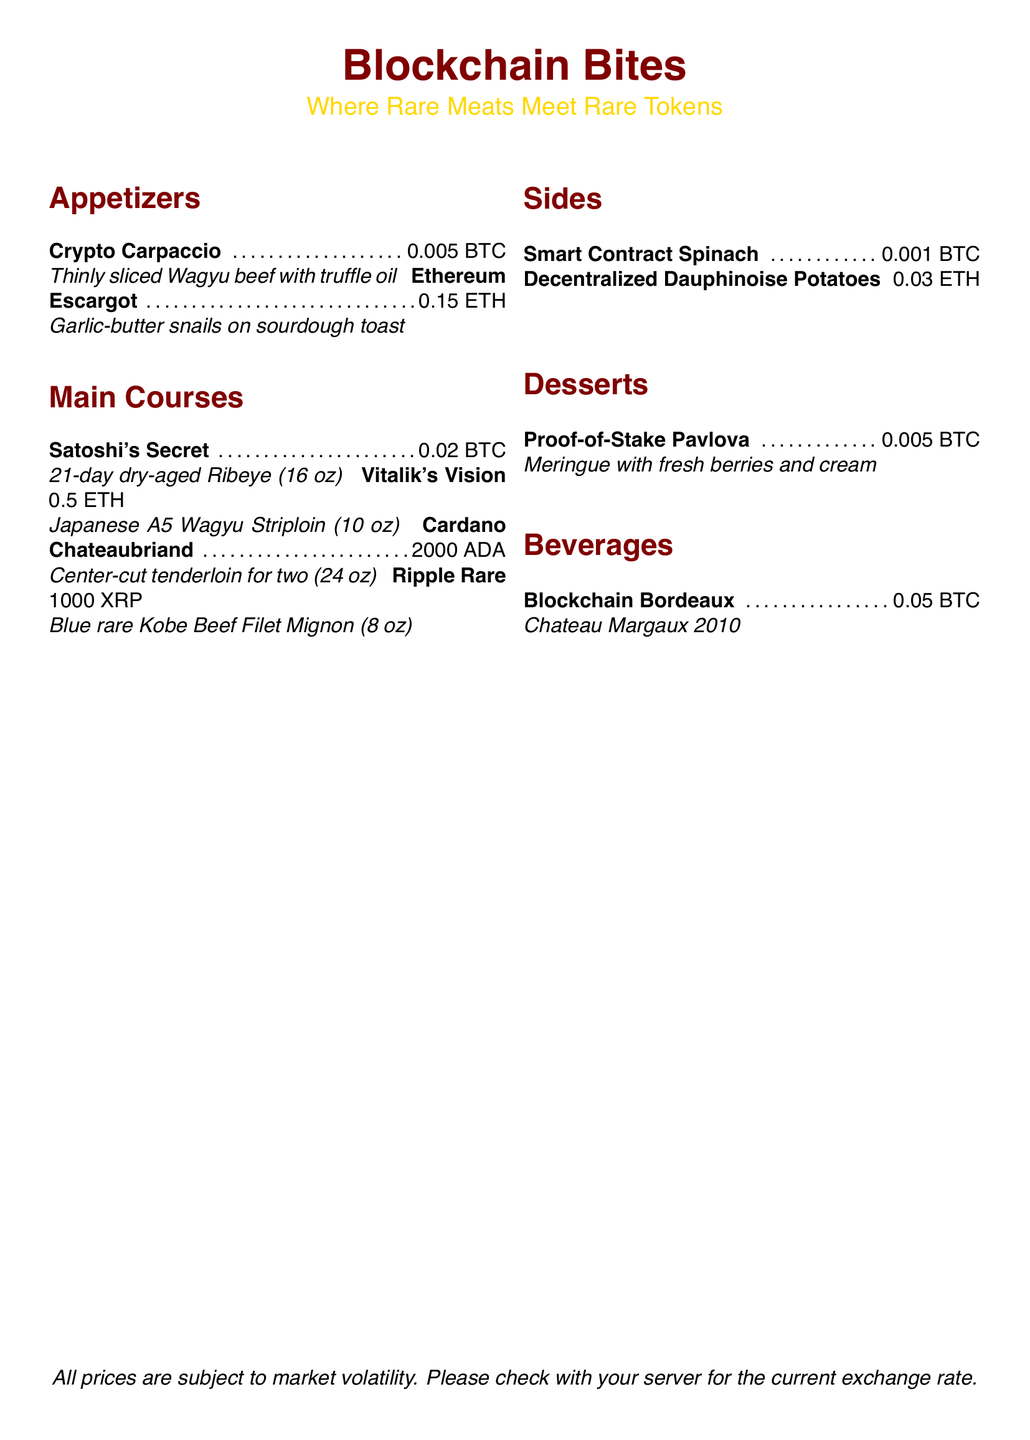What is the name of the appetizer with Wagyu beef? The name of the appetizer is listed under the appetizers section, which is Crypto Carpaccio.
Answer: Crypto Carpaccio How much is the Vitalik's Vision dish? The price of Vitalik's Vision is noted alongside the item under main courses.
Answer: 0.5 ETH What size is the Cardano Chateaubriand? The size is specified in the main courses section, indicating that it is for two people.
Answer: 24 oz Which side dish costs 0.03 ETH? The pricing information for side dishes includes the Decentralized Dauphinoise Potatoes at that price.
Answer: Decentralized Dauphinoise Potatoes How many ounces is the Satoshi's Secret? The document specifies the weight of Satoshi's Secret in ounces under the main courses section.
Answer: 16 oz What type of dessert is offered in the menu? The dessert listed includes a specific name associated with it in the dessert section.
Answer: Proof-of-Stake Pavlova Which beverage has a vintage year mentioned? The beverage section includes a wine with a year, Chateau Margaux 2010.
Answer: Chateau Margaux 2010 How many cryptocurrencies are listed for main courses? The document counts the unique cryptocurrency prices associated with main courses for a total tally.
Answer: 4 